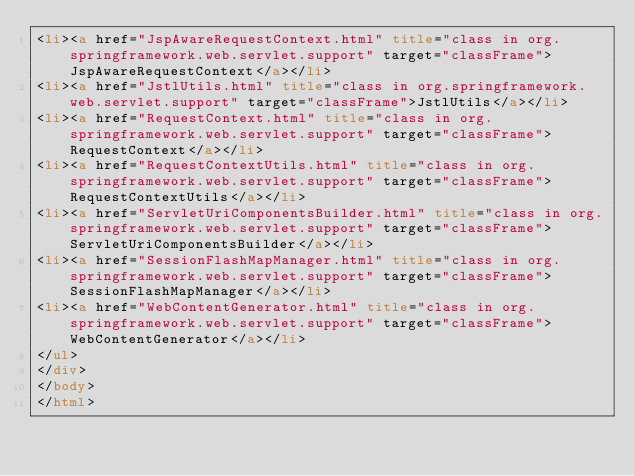<code> <loc_0><loc_0><loc_500><loc_500><_HTML_><li><a href="JspAwareRequestContext.html" title="class in org.springframework.web.servlet.support" target="classFrame">JspAwareRequestContext</a></li>
<li><a href="JstlUtils.html" title="class in org.springframework.web.servlet.support" target="classFrame">JstlUtils</a></li>
<li><a href="RequestContext.html" title="class in org.springframework.web.servlet.support" target="classFrame">RequestContext</a></li>
<li><a href="RequestContextUtils.html" title="class in org.springframework.web.servlet.support" target="classFrame">RequestContextUtils</a></li>
<li><a href="ServletUriComponentsBuilder.html" title="class in org.springframework.web.servlet.support" target="classFrame">ServletUriComponentsBuilder</a></li>
<li><a href="SessionFlashMapManager.html" title="class in org.springframework.web.servlet.support" target="classFrame">SessionFlashMapManager</a></li>
<li><a href="WebContentGenerator.html" title="class in org.springframework.web.servlet.support" target="classFrame">WebContentGenerator</a></li>
</ul>
</div>
</body>
</html>
</code> 